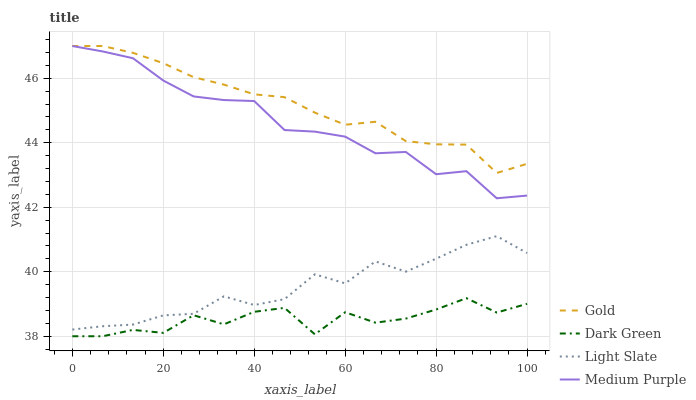Does Dark Green have the minimum area under the curve?
Answer yes or no. Yes. Does Gold have the maximum area under the curve?
Answer yes or no. Yes. Does Medium Purple have the minimum area under the curve?
Answer yes or no. No. Does Medium Purple have the maximum area under the curve?
Answer yes or no. No. Is Gold the smoothest?
Answer yes or no. Yes. Is Dark Green the roughest?
Answer yes or no. Yes. Is Medium Purple the smoothest?
Answer yes or no. No. Is Medium Purple the roughest?
Answer yes or no. No. Does Medium Purple have the lowest value?
Answer yes or no. No. Does Gold have the highest value?
Answer yes or no. Yes. Does Dark Green have the highest value?
Answer yes or no. No. Is Dark Green less than Medium Purple?
Answer yes or no. Yes. Is Medium Purple greater than Dark Green?
Answer yes or no. Yes. Does Dark Green intersect Medium Purple?
Answer yes or no. No. 